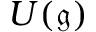Convert formula to latex. <formula><loc_0><loc_0><loc_500><loc_500>U ( { \mathfrak { g } } )</formula> 